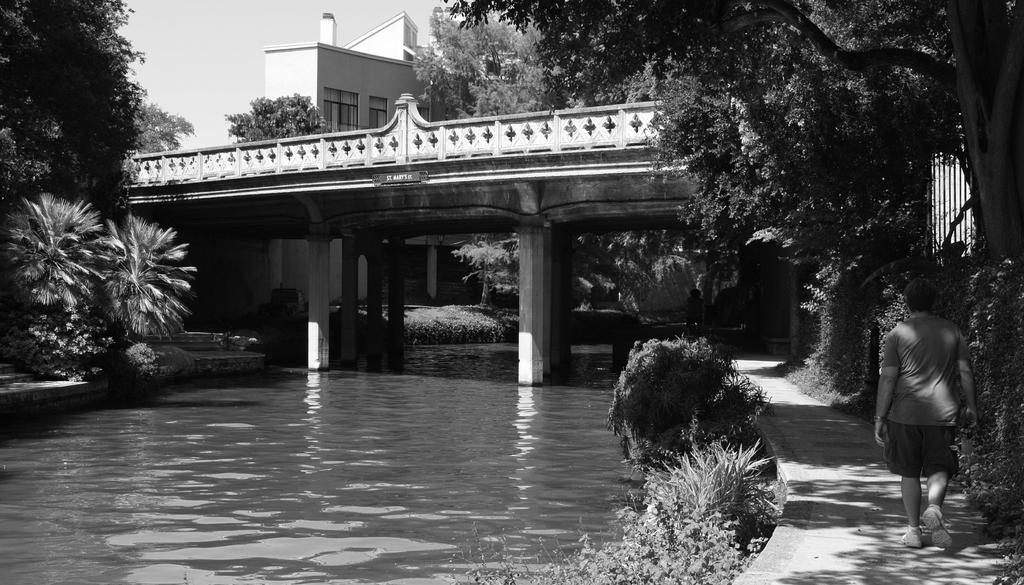What is the person in the image doing? The person is on a path in the image. What can be seen in the background of the image? Water, plants, trees, a building with windows, and a bridge are visible in the image. What type of barrier is present in the image? There is fencing in the image. What is visible in the sky in the image? The sky is visible in the image. What type of paste is being used to construct the doll in the image? There is no doll or paste present in the image. What type of prison can be seen in the image? There is no prison present in the image. 